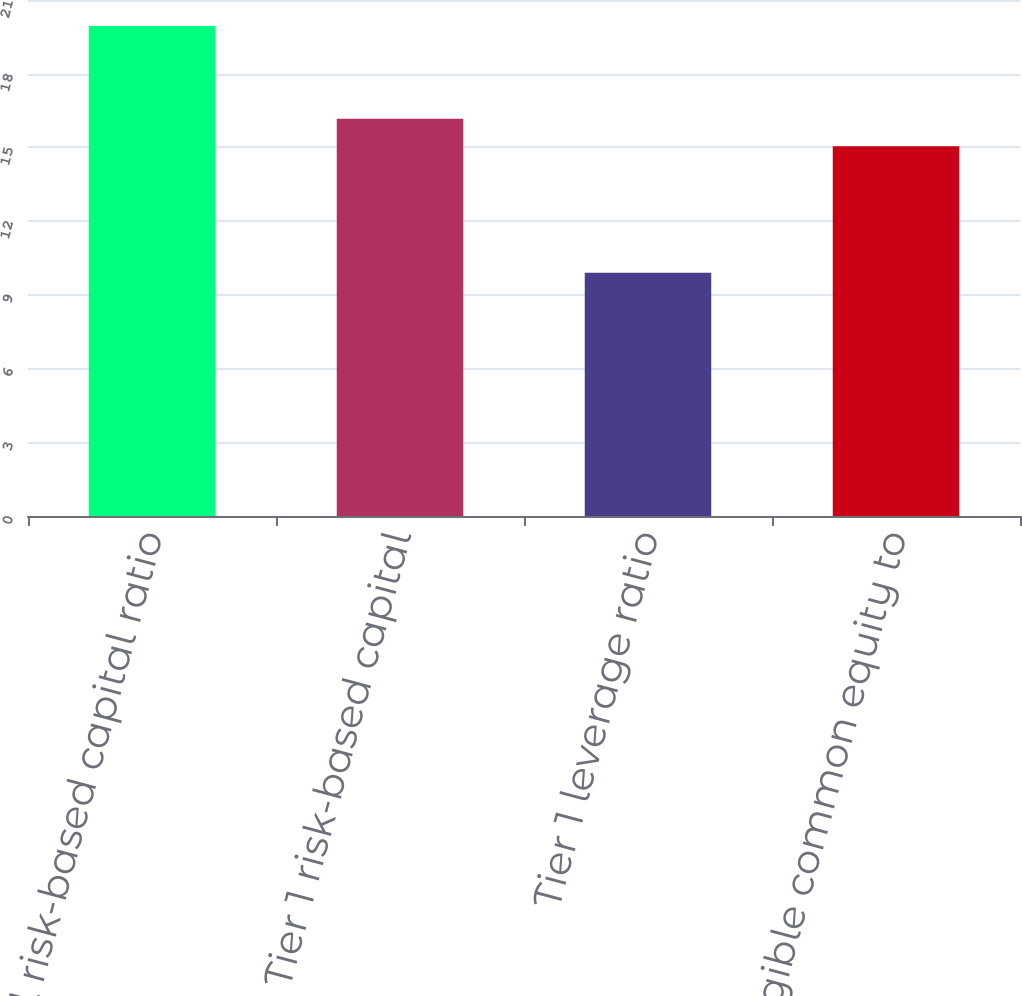<chart> <loc_0><loc_0><loc_500><loc_500><bar_chart><fcel>Total risk-based capital ratio<fcel>Tier 1 risk-based capital<fcel>Tier 1 leverage ratio<fcel>Tangible common equity to<nl><fcel>19.94<fcel>16.17<fcel>9.9<fcel>15.05<nl></chart> 